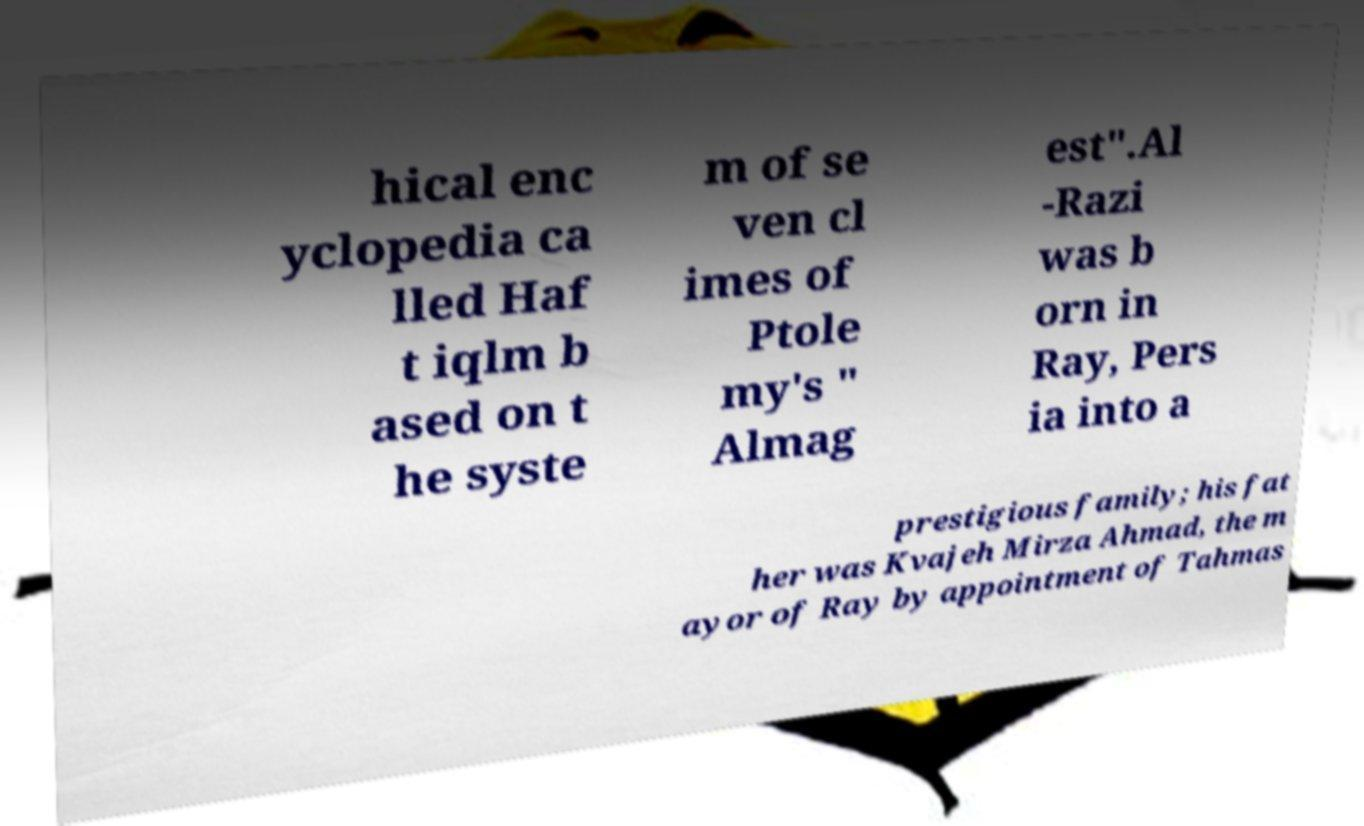For documentation purposes, I need the text within this image transcribed. Could you provide that? hical enc yclopedia ca lled Haf t iqlm b ased on t he syste m of se ven cl imes of Ptole my's " Almag est".Al -Razi was b orn in Ray, Pers ia into a prestigious family; his fat her was Kvajeh Mirza Ahmad, the m ayor of Ray by appointment of Tahmas 